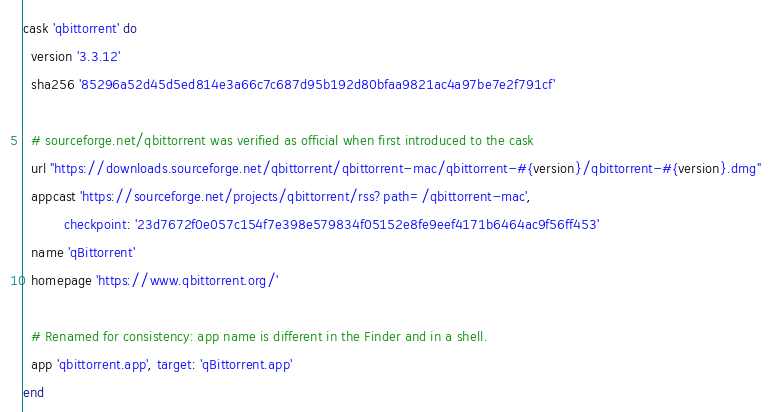Convert code to text. <code><loc_0><loc_0><loc_500><loc_500><_Ruby_>cask 'qbittorrent' do
  version '3.3.12'
  sha256 '85296a52d45d5ed814e3a66c7c687d95b192d80bfaa9821ac4a97be7e2f791cf'

  # sourceforge.net/qbittorrent was verified as official when first introduced to the cask
  url "https://downloads.sourceforge.net/qbittorrent/qbittorrent-mac/qbittorrent-#{version}/qbittorrent-#{version}.dmg"
  appcast 'https://sourceforge.net/projects/qbittorrent/rss?path=/qbittorrent-mac',
          checkpoint: '23d7672f0e057c154f7e398e579834f05152e8fe9eef4171b6464ac9f56ff453'
  name 'qBittorrent'
  homepage 'https://www.qbittorrent.org/'

  # Renamed for consistency: app name is different in the Finder and in a shell.
  app 'qbittorrent.app', target: 'qBittorrent.app'
end
</code> 